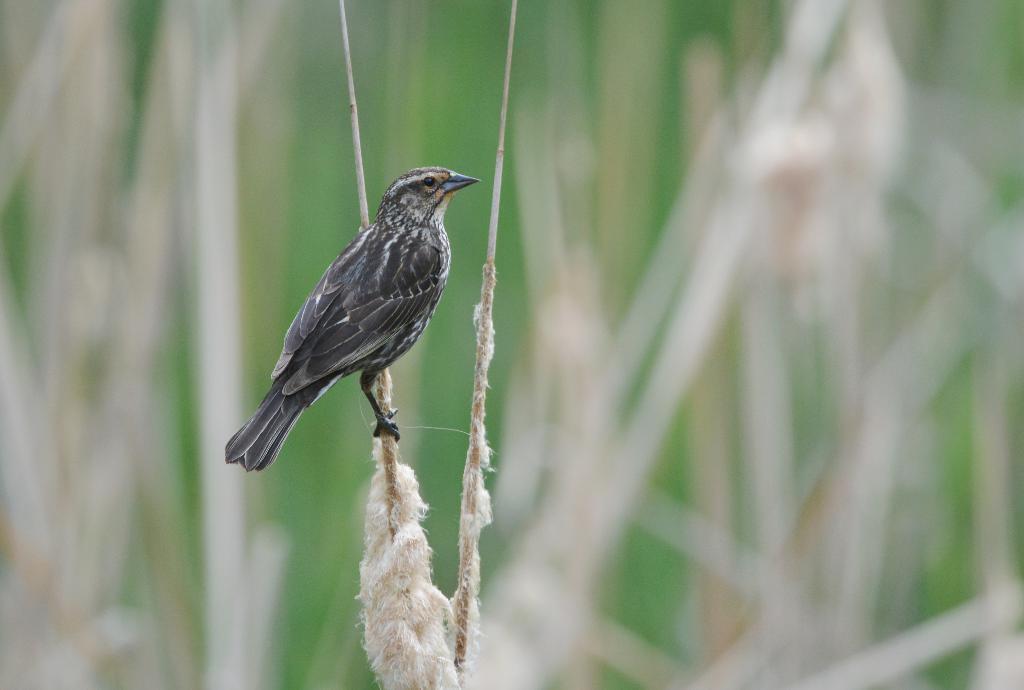How would you summarize this image in a sentence or two? In this image, we can see a bird on a stick. Background there is a blur view. Here we can see another stick. 